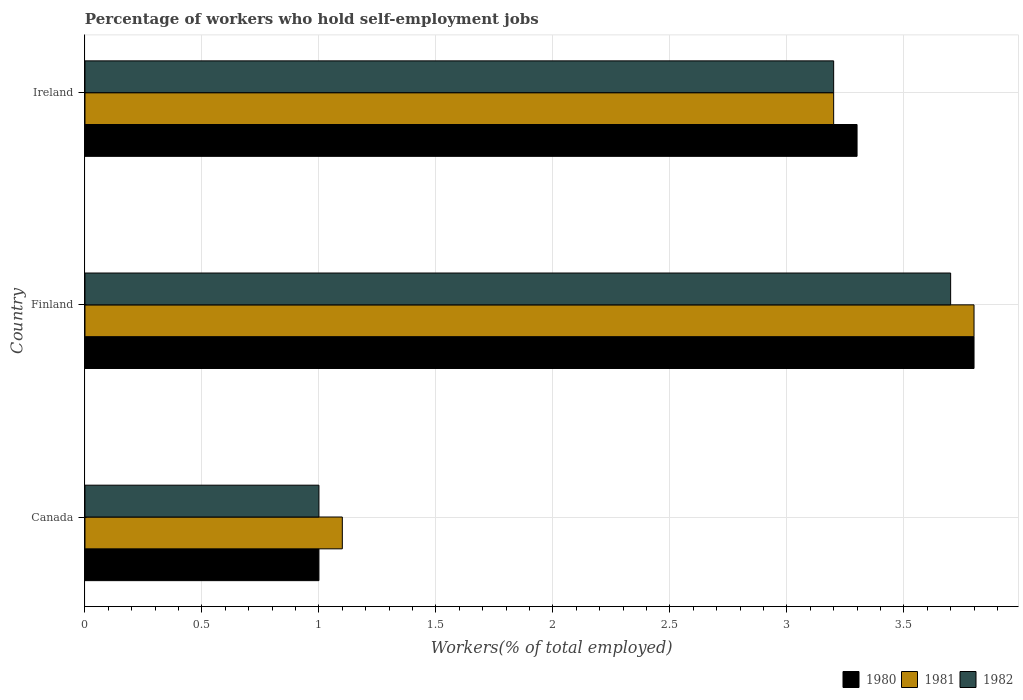How many different coloured bars are there?
Ensure brevity in your answer.  3. Are the number of bars per tick equal to the number of legend labels?
Your answer should be very brief. Yes. How many bars are there on the 1st tick from the top?
Provide a succinct answer. 3. In how many cases, is the number of bars for a given country not equal to the number of legend labels?
Your response must be concise. 0. What is the percentage of self-employed workers in 1981 in Canada?
Ensure brevity in your answer.  1.1. Across all countries, what is the maximum percentage of self-employed workers in 1982?
Provide a succinct answer. 3.7. Across all countries, what is the minimum percentage of self-employed workers in 1981?
Provide a short and direct response. 1.1. In which country was the percentage of self-employed workers in 1980 minimum?
Your answer should be compact. Canada. What is the total percentage of self-employed workers in 1980 in the graph?
Your answer should be compact. 8.1. What is the difference between the percentage of self-employed workers in 1981 in Canada and that in Ireland?
Your answer should be compact. -2.1. What is the difference between the percentage of self-employed workers in 1982 in Ireland and the percentage of self-employed workers in 1981 in Finland?
Provide a short and direct response. -0.6. What is the average percentage of self-employed workers in 1980 per country?
Your answer should be very brief. 2.7. What is the difference between the percentage of self-employed workers in 1982 and percentage of self-employed workers in 1981 in Canada?
Provide a succinct answer. -0.1. In how many countries, is the percentage of self-employed workers in 1981 greater than 0.5 %?
Offer a very short reply. 3. What is the ratio of the percentage of self-employed workers in 1980 in Finland to that in Ireland?
Make the answer very short. 1.15. Is the percentage of self-employed workers in 1982 in Canada less than that in Ireland?
Your response must be concise. Yes. What is the difference between the highest and the second highest percentage of self-employed workers in 1981?
Keep it short and to the point. 0.6. What is the difference between the highest and the lowest percentage of self-employed workers in 1980?
Provide a succinct answer. 2.8. What does the 1st bar from the bottom in Finland represents?
Offer a very short reply. 1980. Is it the case that in every country, the sum of the percentage of self-employed workers in 1982 and percentage of self-employed workers in 1980 is greater than the percentage of self-employed workers in 1981?
Provide a succinct answer. Yes. How many bars are there?
Your answer should be compact. 9. Are all the bars in the graph horizontal?
Ensure brevity in your answer.  Yes. Are the values on the major ticks of X-axis written in scientific E-notation?
Your answer should be very brief. No. Does the graph contain any zero values?
Offer a terse response. No. Does the graph contain grids?
Your response must be concise. Yes. Where does the legend appear in the graph?
Provide a short and direct response. Bottom right. How many legend labels are there?
Your answer should be compact. 3. What is the title of the graph?
Your answer should be very brief. Percentage of workers who hold self-employment jobs. Does "1982" appear as one of the legend labels in the graph?
Your answer should be very brief. Yes. What is the label or title of the X-axis?
Make the answer very short. Workers(% of total employed). What is the Workers(% of total employed) in 1980 in Canada?
Provide a succinct answer. 1. What is the Workers(% of total employed) in 1981 in Canada?
Offer a terse response. 1.1. What is the Workers(% of total employed) in 1982 in Canada?
Make the answer very short. 1. What is the Workers(% of total employed) in 1980 in Finland?
Make the answer very short. 3.8. What is the Workers(% of total employed) in 1981 in Finland?
Ensure brevity in your answer.  3.8. What is the Workers(% of total employed) in 1982 in Finland?
Give a very brief answer. 3.7. What is the Workers(% of total employed) of 1980 in Ireland?
Offer a terse response. 3.3. What is the Workers(% of total employed) of 1981 in Ireland?
Offer a very short reply. 3.2. What is the Workers(% of total employed) in 1982 in Ireland?
Your response must be concise. 3.2. Across all countries, what is the maximum Workers(% of total employed) in 1980?
Offer a very short reply. 3.8. Across all countries, what is the maximum Workers(% of total employed) of 1981?
Your answer should be very brief. 3.8. Across all countries, what is the maximum Workers(% of total employed) in 1982?
Your answer should be compact. 3.7. Across all countries, what is the minimum Workers(% of total employed) in 1981?
Provide a succinct answer. 1.1. What is the total Workers(% of total employed) of 1980 in the graph?
Provide a succinct answer. 8.1. What is the total Workers(% of total employed) of 1981 in the graph?
Give a very brief answer. 8.1. What is the total Workers(% of total employed) in 1982 in the graph?
Your answer should be compact. 7.9. What is the difference between the Workers(% of total employed) in 1981 in Canada and that in Finland?
Your answer should be compact. -2.7. What is the difference between the Workers(% of total employed) of 1982 in Canada and that in Finland?
Your answer should be compact. -2.7. What is the difference between the Workers(% of total employed) of 1980 in Canada and that in Ireland?
Offer a very short reply. -2.3. What is the difference between the Workers(% of total employed) of 1981 in Canada and that in Ireland?
Keep it short and to the point. -2.1. What is the difference between the Workers(% of total employed) in 1982 in Canada and that in Ireland?
Keep it short and to the point. -2.2. What is the difference between the Workers(% of total employed) of 1980 in Finland and that in Ireland?
Your answer should be very brief. 0.5. What is the difference between the Workers(% of total employed) in 1982 in Finland and that in Ireland?
Provide a succinct answer. 0.5. What is the difference between the Workers(% of total employed) in 1980 in Canada and the Workers(% of total employed) in 1981 in Finland?
Make the answer very short. -2.8. What is the difference between the Workers(% of total employed) in 1981 in Canada and the Workers(% of total employed) in 1982 in Ireland?
Give a very brief answer. -2.1. What is the difference between the Workers(% of total employed) in 1980 in Finland and the Workers(% of total employed) in 1981 in Ireland?
Offer a very short reply. 0.6. What is the difference between the Workers(% of total employed) in 1980 in Finland and the Workers(% of total employed) in 1982 in Ireland?
Provide a short and direct response. 0.6. What is the difference between the Workers(% of total employed) of 1981 in Finland and the Workers(% of total employed) of 1982 in Ireland?
Give a very brief answer. 0.6. What is the average Workers(% of total employed) of 1982 per country?
Make the answer very short. 2.63. What is the difference between the Workers(% of total employed) in 1980 and Workers(% of total employed) in 1981 in Canada?
Give a very brief answer. -0.1. What is the difference between the Workers(% of total employed) of 1980 and Workers(% of total employed) of 1982 in Canada?
Keep it short and to the point. 0. What is the difference between the Workers(% of total employed) in 1981 and Workers(% of total employed) in 1982 in Canada?
Provide a succinct answer. 0.1. What is the difference between the Workers(% of total employed) in 1980 and Workers(% of total employed) in 1982 in Finland?
Provide a succinct answer. 0.1. What is the difference between the Workers(% of total employed) in 1980 and Workers(% of total employed) in 1982 in Ireland?
Ensure brevity in your answer.  0.1. What is the difference between the Workers(% of total employed) in 1981 and Workers(% of total employed) in 1982 in Ireland?
Ensure brevity in your answer.  0. What is the ratio of the Workers(% of total employed) of 1980 in Canada to that in Finland?
Ensure brevity in your answer.  0.26. What is the ratio of the Workers(% of total employed) in 1981 in Canada to that in Finland?
Your answer should be very brief. 0.29. What is the ratio of the Workers(% of total employed) of 1982 in Canada to that in Finland?
Your response must be concise. 0.27. What is the ratio of the Workers(% of total employed) of 1980 in Canada to that in Ireland?
Offer a terse response. 0.3. What is the ratio of the Workers(% of total employed) of 1981 in Canada to that in Ireland?
Your answer should be very brief. 0.34. What is the ratio of the Workers(% of total employed) in 1982 in Canada to that in Ireland?
Ensure brevity in your answer.  0.31. What is the ratio of the Workers(% of total employed) of 1980 in Finland to that in Ireland?
Give a very brief answer. 1.15. What is the ratio of the Workers(% of total employed) of 1981 in Finland to that in Ireland?
Offer a very short reply. 1.19. What is the ratio of the Workers(% of total employed) in 1982 in Finland to that in Ireland?
Your answer should be compact. 1.16. What is the difference between the highest and the second highest Workers(% of total employed) of 1982?
Offer a terse response. 0.5. What is the difference between the highest and the lowest Workers(% of total employed) in 1981?
Keep it short and to the point. 2.7. What is the difference between the highest and the lowest Workers(% of total employed) in 1982?
Your response must be concise. 2.7. 